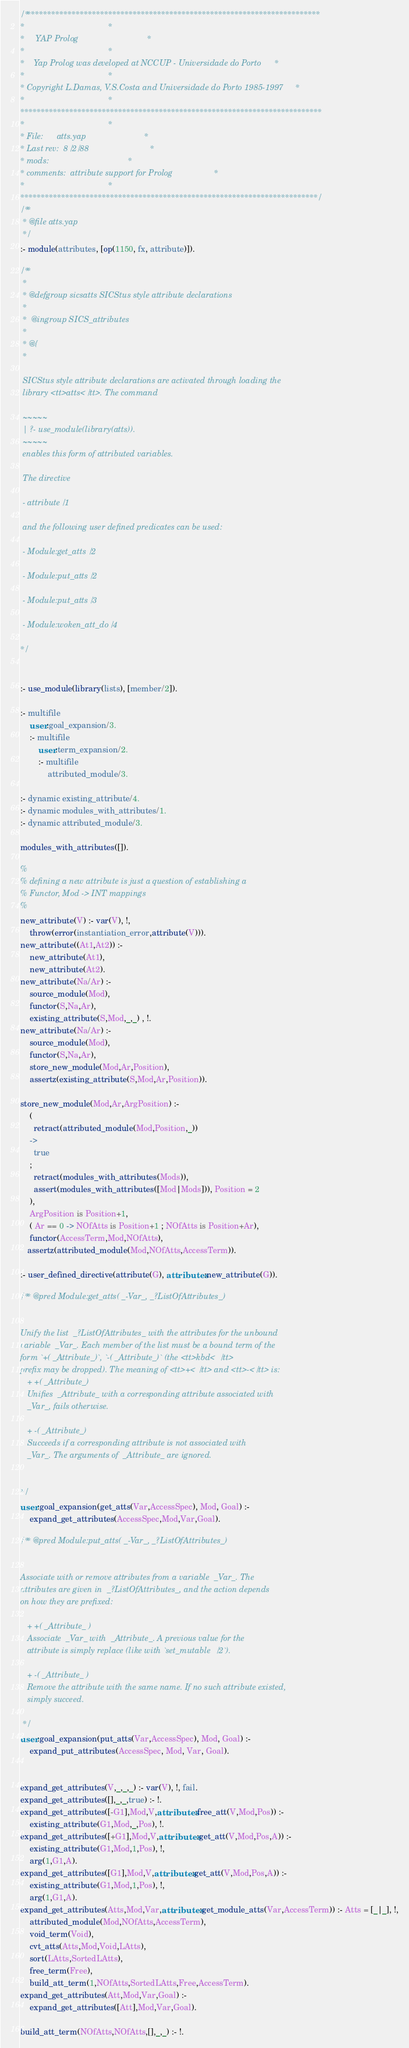<code> <loc_0><loc_0><loc_500><loc_500><_Prolog_>/*************************************************************************
*									 *
*	 YAP Prolog 							 *
*									 *
*	Yap Prolog was developed at NCCUP - Universidade do Porto	 *
*									 *
* Copyright L.Damas, V.S.Costa and Universidade do Porto 1985-1997	 *
*									 *
**************************************************************************
*									 *
* File:		atts.yap						 *
* Last rev:	8/2/88							 *
* mods:									 *
* comments:	attribute support for Prolog				 *
*									 *
*************************************************************************/
/**
 * @file atts.yap
 */
:- module(attributes, [op(1150, fx, attribute)]).

/**
 *
 * @defgroup sicsatts SICStus style attribute declarations
 *
 *  @ingroup SICS_attributes
 *
 * @{
 *

 SICStus style attribute declarations are activated through loading the
 library <tt>atts</tt>. The command

 ~~~~~
 | ?- use_module(library(atts)).
 ~~~~~
 enables this form of attributed variables.

 The directive

 - attribute/1

 and the following user defined predicates can be used:

 - Module:get_atts/2

 - Module:put_atts/2

 - Module:put_atts/3

 - Module:woken_att_do/4

*/


:- use_module(library(lists), [member/2]).

:- multifile
	user:goal_expansion/3.
    :- multifile
    	user:term_expansion/2.
        :- multifile
        	attributed_module/3.

:- dynamic existing_attribute/4.
:- dynamic modules_with_attributes/1.
:- dynamic attributed_module/3.

modules_with_attributes([]).

%
% defining a new attribute is just a question of establishing a
% Functor, Mod -> INT mappings
%
new_attribute(V) :- var(V), !,
	throw(error(instantiation_error,attribute(V))).
new_attribute((At1,At2)) :-
	new_attribute(At1),
	new_attribute(At2).
new_attribute(Na/Ar) :-
	source_module(Mod),
	functor(S,Na,Ar),
	existing_attribute(S,Mod,_,_) , !.
new_attribute(Na/Ar) :-
	source_module(Mod),
	functor(S,Na,Ar),
	store_new_module(Mod,Ar,Position),
	assertz(existing_attribute(S,Mod,Ar,Position)).

store_new_module(Mod,Ar,ArgPosition) :-
	(
	  retract(attributed_module(Mod,Position,_))
	->
	  true
	;
	  retract(modules_with_attributes(Mods)),
	  assert(modules_with_attributes([Mod|Mods])), Position = 2
	),
	ArgPosition is Position+1,
	( Ar == 0 -> NOfAtts is Position+1 ; NOfAtts is Position+Ar),
	functor(AccessTerm,Mod,NOfAtts),
   assertz(attributed_module(Mod,NOfAtts,AccessTerm)).

:- user_defined_directive(attribute(G), attributes:new_attribute(G)).

/** @pred Module:get_atts( _-Var_, _?ListOfAttributes_)


Unify the list  _?ListOfAttributes_ with the attributes for the unbound
variable  _Var_. Each member of the list must be a bound term of the
form `+( _Attribute_)`, `-( _Attribute_)` (the <tt>kbd</tt>
prefix may be dropped). The meaning of <tt>+</tt> and <tt>-</tt> is:
   + +( _Attribute_)
   Unifies  _Attribute_ with a corresponding attribute associated with
   _Var_, fails otherwise.

   + -( _Attribute_)
   Succeeds if a corresponding attribute is not associated with
   _Var_. The arguments of  _Attribute_ are ignored.


*/
user:goal_expansion(get_atts(Var,AccessSpec), Mod, Goal) :-
	expand_get_attributes(AccessSpec,Mod,Var,Goal).

/** @pred Module:put_atts( _-Var_, _?ListOfAttributes_)


Associate with or remove attributes from a variable  _Var_. The
attributes are given in  _?ListOfAttributes_, and the action depends
on how they are prefixed:

   + +( _Attribute_ )
   Associate  _Var_ with  _Attribute_. A previous value for the
   attribute is simply replace (like with `set_mutable/2`).

   + -( _Attribute_ )
   Remove the attribute with the same name. If no such attribute existed,
   simply succeed.

 */
user:goal_expansion(put_atts(Var,AccessSpec), Mod, Goal) :-
	expand_put_attributes(AccessSpec, Mod, Var, Goal).


expand_get_attributes(V,_,_,_) :- var(V), !, fail.
expand_get_attributes([],_,_,true) :- !.
expand_get_attributes([-G1],Mod,V,attributes:free_att(V,Mod,Pos)) :-
	existing_attribute(G1,Mod,_,Pos), !.
expand_get_attributes([+G1],Mod,V,attributes:get_att(V,Mod,Pos,A)) :-
	existing_attribute(G1,Mod,1,Pos), !,
	arg(1,G1,A).
expand_get_attributes([G1],Mod,V,attributes:get_att(V,Mod,Pos,A)) :-
	existing_attribute(G1,Mod,1,Pos), !,
	arg(1,G1,A).
expand_get_attributes(Atts,Mod,Var,attributes:get_module_atts(Var,AccessTerm)) :- Atts = [_|_], !,
	attributed_module(Mod,NOfAtts,AccessTerm),
	void_term(Void),
	cvt_atts(Atts,Mod,Void,LAtts),
	sort(LAtts,SortedLAtts),
	free_term(Free),
	build_att_term(1,NOfAtts,SortedLAtts,Free,AccessTerm).
expand_get_attributes(Att,Mod,Var,Goal) :-
	expand_get_attributes([Att],Mod,Var,Goal).

build_att_term(NOfAtts,NOfAtts,[],_,_) :- !.</code> 